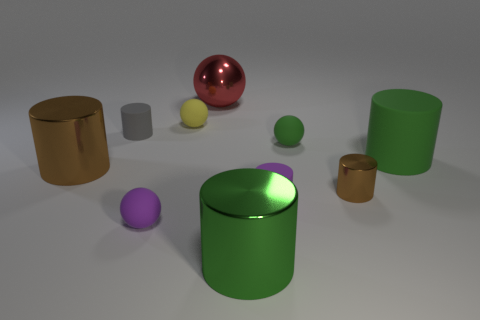Does the purple matte object that is on the left side of the small purple matte cylinder have the same shape as the yellow object?
Your response must be concise. Yes. What number of small things are either metal balls or red metallic cylinders?
Give a very brief answer. 0. Are there an equal number of large metal objects to the right of the gray matte cylinder and big brown metallic cylinders that are behind the tiny green matte object?
Ensure brevity in your answer.  No. What number of other things are there of the same color as the small metal cylinder?
Give a very brief answer. 1. Does the big matte object have the same color as the small matte ball that is left of the yellow sphere?
Ensure brevity in your answer.  No. How many blue things are either small cylinders or small metal objects?
Your answer should be compact. 0. Are there the same number of spheres behind the shiny sphere and gray rubber cylinders?
Give a very brief answer. No. Is there any other thing that has the same size as the purple rubber ball?
Provide a succinct answer. Yes. There is a big rubber object that is the same shape as the small brown metallic object; what is its color?
Give a very brief answer. Green. What number of big green objects have the same shape as the gray rubber thing?
Ensure brevity in your answer.  2. 